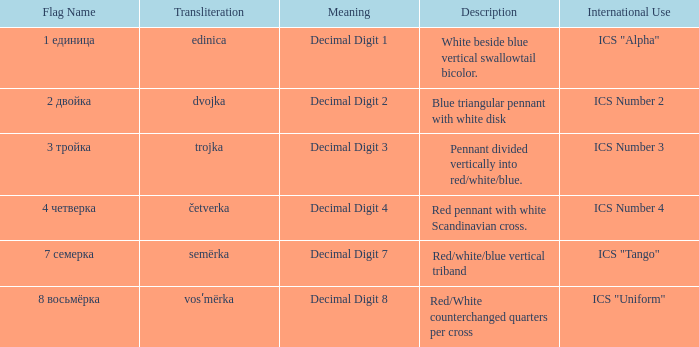What are the meanings of the flag whose name transliterates to dvojka? Decimal Digit 2. 